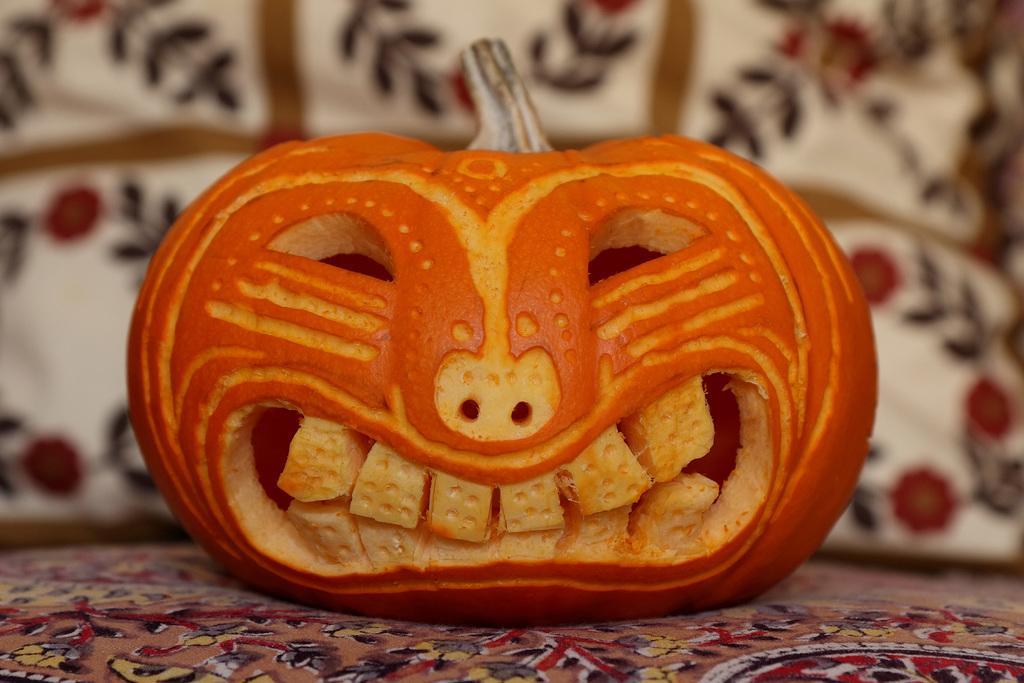What is the main object in the image? There is a pumpkin in the image. What color is the pumpkin? The pumpkin is orange in color. What is unique about the appearance of the pumpkin? The pumpkin is shaped like a human face. What can be seen behind the pumpkin? There appears to be a pillow behind the pumpkin. What type of material is visible at the bottom of the image? There is cloth visible at the bottom of the image. How many sticks are used to support the pumpkin in the image? There are no sticks visible in the image, and the pumpkin is not being supported by any sticks. Is the pumpkin being used as a pillow for someone to sleep on in the image? No, the pumpkin is not being used as a pillow for someone to sleep on in the image. 